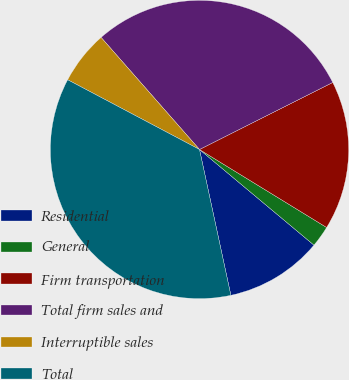<chart> <loc_0><loc_0><loc_500><loc_500><pie_chart><fcel>Residential<fcel>General<fcel>Firm transportation<fcel>Total firm sales and<fcel>Interruptible sales<fcel>Total<nl><fcel>10.55%<fcel>2.32%<fcel>16.18%<fcel>29.05%<fcel>5.79%<fcel>36.12%<nl></chart> 